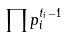<formula> <loc_0><loc_0><loc_500><loc_500>\prod p _ { i } ^ { t _ { i } - 1 }</formula> 